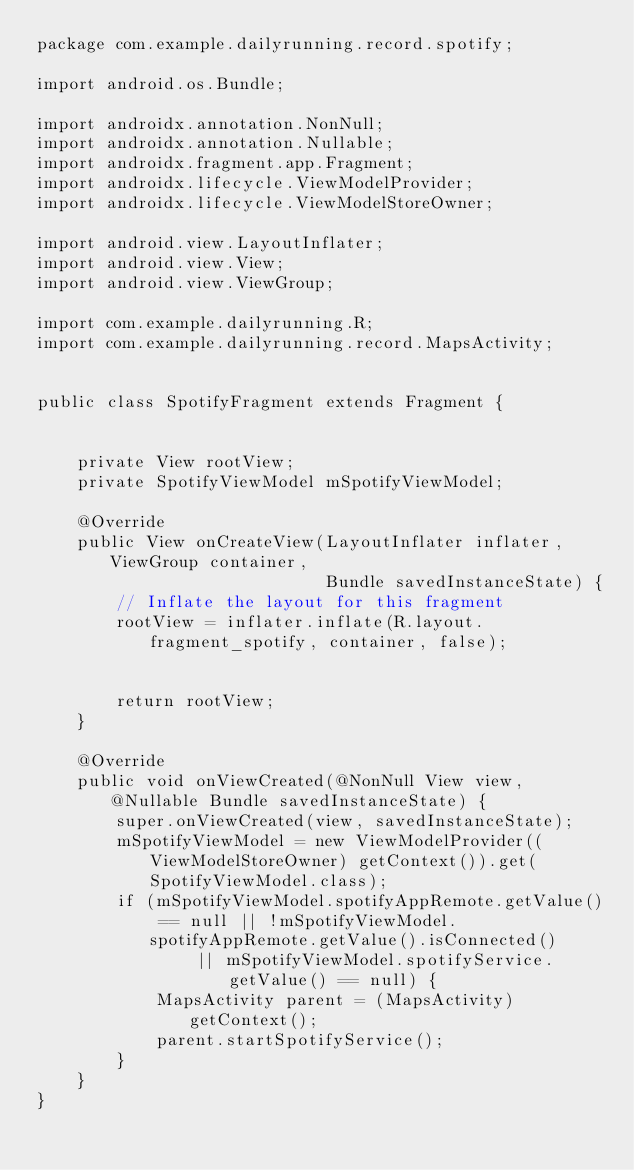<code> <loc_0><loc_0><loc_500><loc_500><_Java_>package com.example.dailyrunning.record.spotify;

import android.os.Bundle;

import androidx.annotation.NonNull;
import androidx.annotation.Nullable;
import androidx.fragment.app.Fragment;
import androidx.lifecycle.ViewModelProvider;
import androidx.lifecycle.ViewModelStoreOwner;

import android.view.LayoutInflater;
import android.view.View;
import android.view.ViewGroup;

import com.example.dailyrunning.R;
import com.example.dailyrunning.record.MapsActivity;


public class SpotifyFragment extends Fragment {


    private View rootView;
    private SpotifyViewModel mSpotifyViewModel;

    @Override
    public View onCreateView(LayoutInflater inflater, ViewGroup container,
                             Bundle savedInstanceState) {
        // Inflate the layout for this fragment
        rootView = inflater.inflate(R.layout.fragment_spotify, container, false);


        return rootView;
    }

    @Override
    public void onViewCreated(@NonNull View view, @Nullable Bundle savedInstanceState) {
        super.onViewCreated(view, savedInstanceState);
        mSpotifyViewModel = new ViewModelProvider((ViewModelStoreOwner) getContext()).get(SpotifyViewModel.class);
        if (mSpotifyViewModel.spotifyAppRemote.getValue() == null || !mSpotifyViewModel.spotifyAppRemote.getValue().isConnected()
                || mSpotifyViewModel.spotifyService.getValue() == null) {
            MapsActivity parent = (MapsActivity) getContext();
            parent.startSpotifyService();
        }
    }
}</code> 